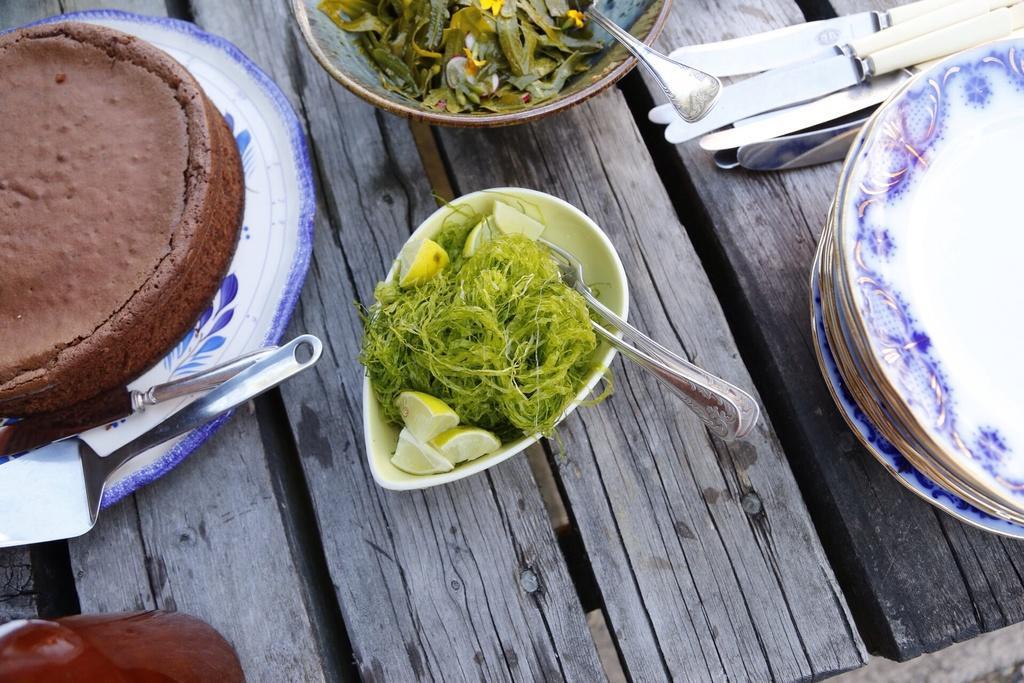In one or two sentences, can you explain what this image depicts? In the image we can see the wooden table, on the table, we can see the plates, bowls and knives. We can even see food in the plate and in the bowl. 